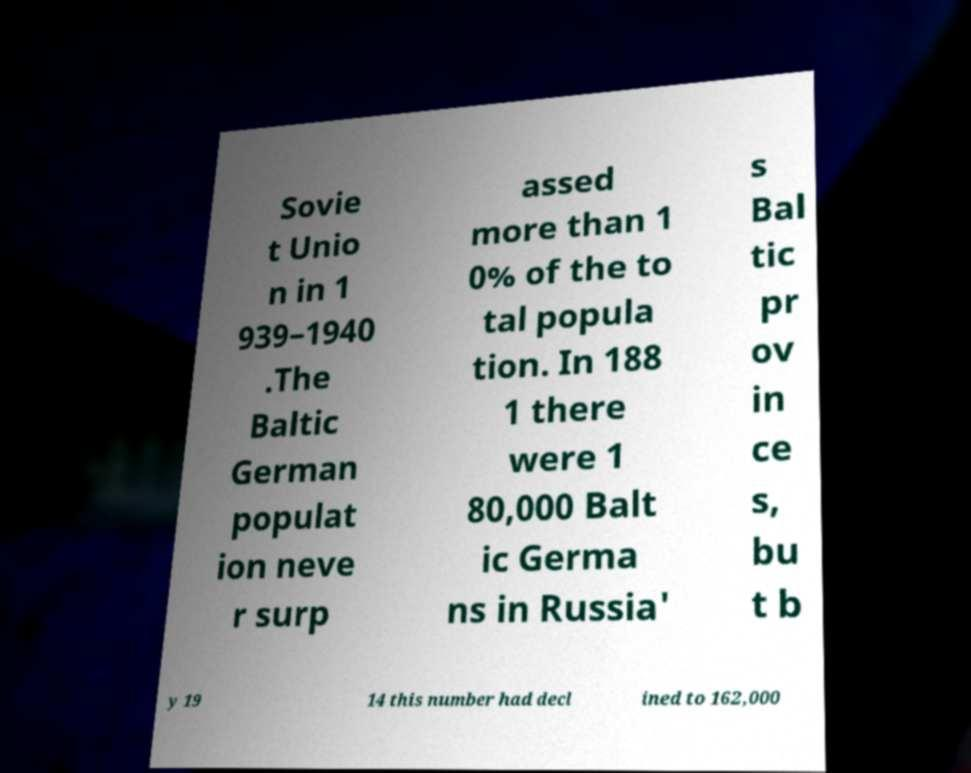Can you accurately transcribe the text from the provided image for me? Sovie t Unio n in 1 939–1940 .The Baltic German populat ion neve r surp assed more than 1 0% of the to tal popula tion. In 188 1 there were 1 80,000 Balt ic Germa ns in Russia' s Bal tic pr ov in ce s, bu t b y 19 14 this number had decl ined to 162,000 